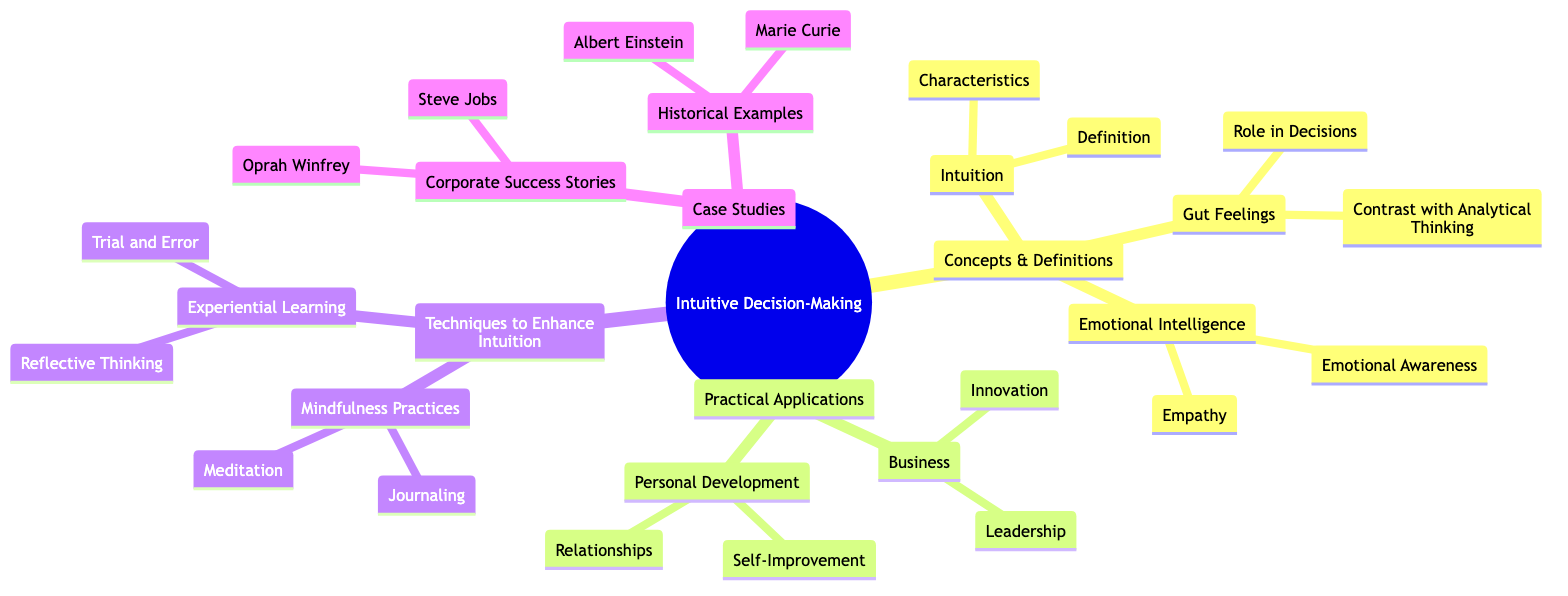What are the two main categories in the mind map? The two main categories in the mind map are "Concepts & Definitions" and "Practical Applications". These can be found as the top-level nodes branching from the root node labeled "Intuitive Decision-Making".
Answer: "Concepts & Definitions", "Practical Applications" How many children does the node "Techniques to Enhance Intuition" have? The node "Techniques to Enhance Intuition" has two children nodes, which are "Mindfulness Practices" and "Experiential Learning". By counting these nodes, we can find the total.
Answer: 2 What is the relationship between "Emotional Intelligence" and "Empathy"? "Empathy" is a child of the parent node "Emotional Intelligence". This means that "Empathy" directly falls under the broader category of "Emotional Intelligence".
Answer: "Empathy" is a child of "Emotional Intelligence" Which historical example is listed in the case studies? The historical examples in the case studies include "Albert Einstein" and "Marie Curie". You can identify these by looking at the branch that connects to "Historical Examples".
Answer: "Albert Einstein", "Marie Curie" What two areas does "Business" apply intuitive decision-making to? "Business" applies intuitive decision-making to "Leadership" and "Innovation". This is represented by the two children nodes under "Business".
Answer: "Leadership", "Innovation" What techniques are recommended to enhance intuition in the mind map? The mind map suggests "Mindfulness Practices" and "Experiential Learning" as the techniques to enhance intuition. These are the primary branches stemming from the “Techniques to Enhance Intuition” node.
Answer: "Mindfulness Practices", "Experiential Learning" How many case studies are mentioned in the mind map? There are four case studies mentioned in the mind map: "Steve Jobs," "Oprah Winfrey," "Albert Einstein," and "Marie Curie". Counting all names provides the total.
Answer: 4 What role do gut feelings play in decision-making according to the diagram? The role of "Gut Feelings" in decisions is described under the node "Role in Decisions", which is a child of the parent node "Gut Feelings". It signifies the importance of instinctual responses in making choices.
Answer: "Role in Decisions" 